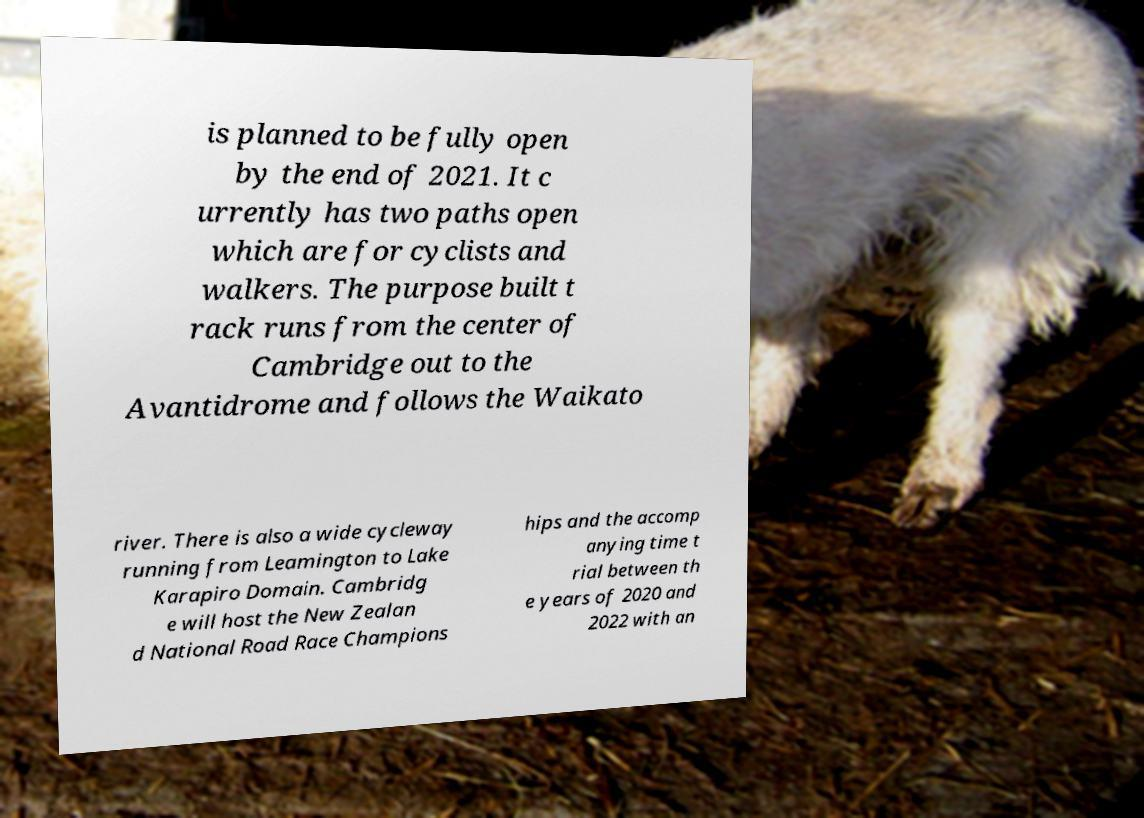There's text embedded in this image that I need extracted. Can you transcribe it verbatim? is planned to be fully open by the end of 2021. It c urrently has two paths open which are for cyclists and walkers. The purpose built t rack runs from the center of Cambridge out to the Avantidrome and follows the Waikato river. There is also a wide cycleway running from Leamington to Lake Karapiro Domain. Cambridg e will host the New Zealan d National Road Race Champions hips and the accomp anying time t rial between th e years of 2020 and 2022 with an 